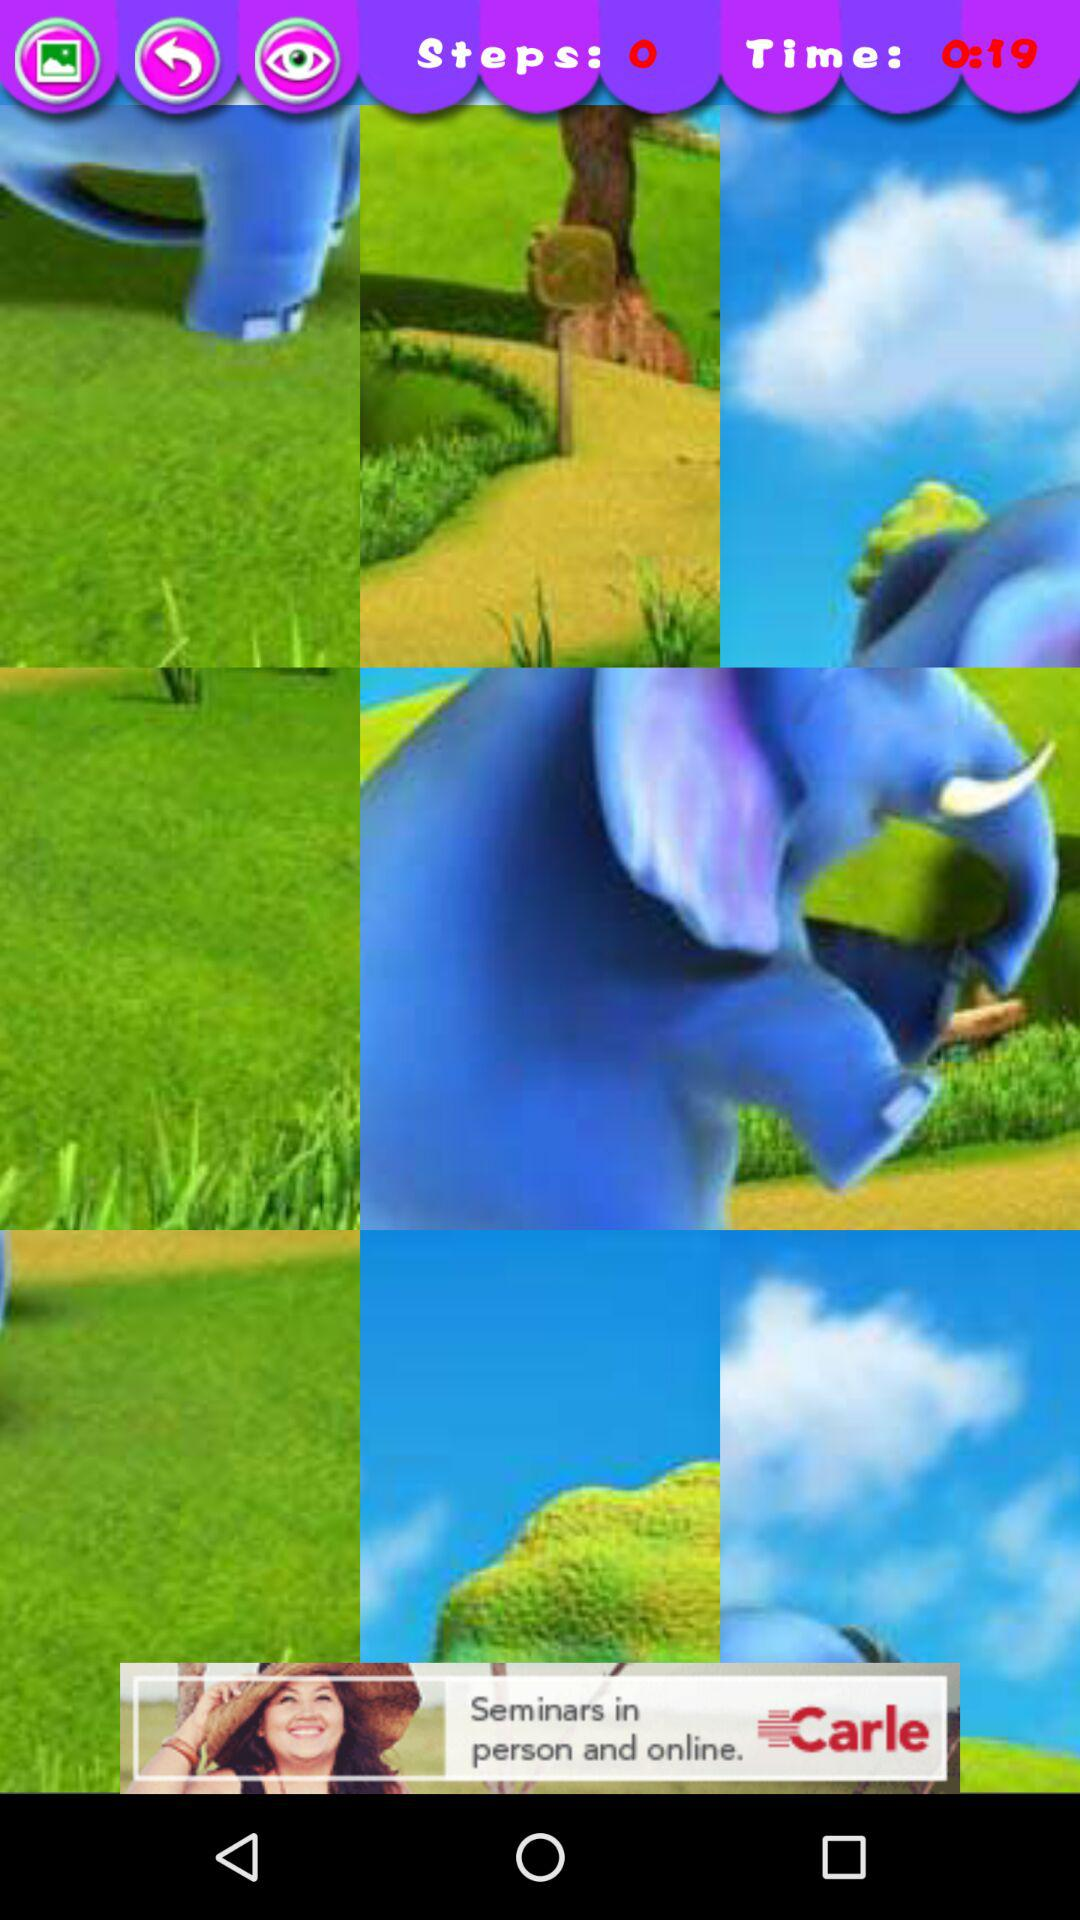What is the remaining time? The remaining time is 19 seconds. 